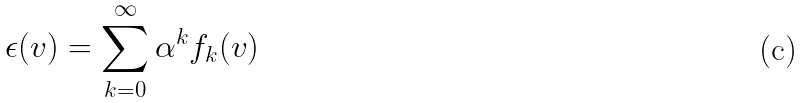<formula> <loc_0><loc_0><loc_500><loc_500>\epsilon ( v ) = \sum _ { k = 0 } ^ { \infty } \alpha ^ { k } f _ { k } ( v )</formula> 